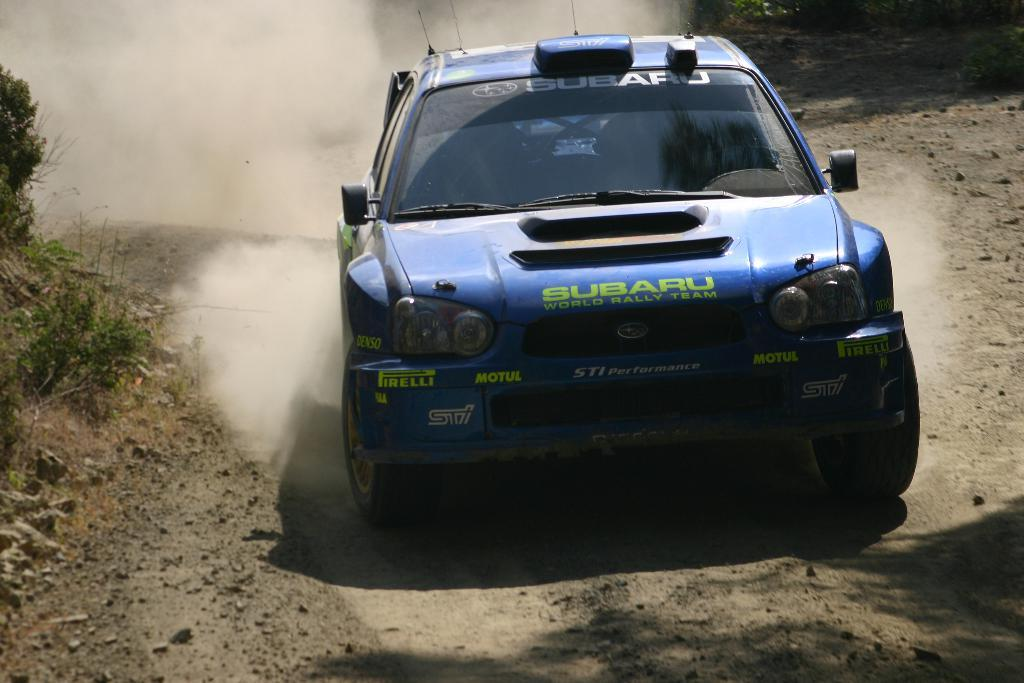What type of vehicle is in the foreground of the image? There is a sports car in the foreground of the image. What is the position of the sports car in the image? The sports car is on the ground. What can be seen in the background of the image? There is smoke and plants visible in the background of the image. What is the price of the birthday trade in the image? There is no mention of a birthday trade in the image, so it is not possible to determine its price. 